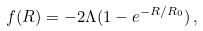<formula> <loc_0><loc_0><loc_500><loc_500>f ( R ) = - 2 \Lambda ( 1 - e ^ { - R / R _ { 0 } } ) \, ,</formula> 